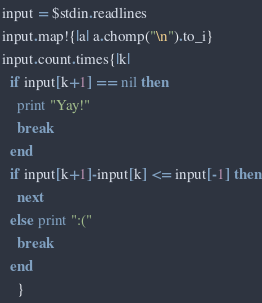<code> <loc_0><loc_0><loc_500><loc_500><_Ruby_>input = $stdin.readlines
input.map!{|a| a.chomp("\n").to_i}
input.count.times{|k|
  if input[k+1] == nil then
    print "Yay!"
    break
  end
  if input[k+1]-input[k] <= input[-1] then
    next
  else print ":("
    break
  end
    }</code> 